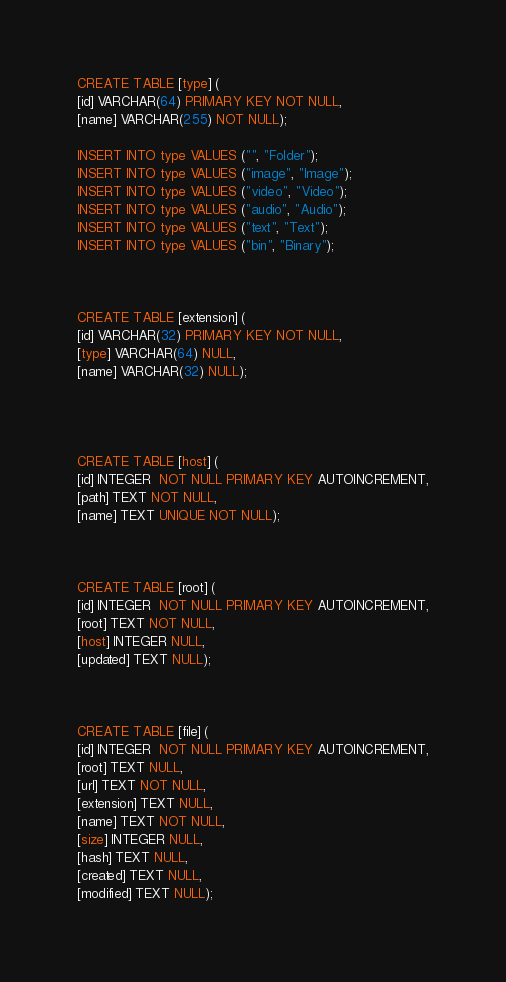Convert code to text. <code><loc_0><loc_0><loc_500><loc_500><_SQL_>
CREATE TABLE [type] (
[id] VARCHAR(64) PRIMARY KEY NOT NULL,
[name] VARCHAR(255) NOT NULL);

INSERT INTO type VALUES ("", "Folder");
INSERT INTO type VALUES ("image", "Image");
INSERT INTO type VALUES ("video", "Video");
INSERT INTO type VALUES ("audio", "Audio");
INSERT INTO type VALUES ("text", "Text");
INSERT INTO type VALUES ("bin", "Binary");



CREATE TABLE [extension] (
[id] VARCHAR(32) PRIMARY KEY NOT NULL,
[type] VARCHAR(64) NULL,
[name] VARCHAR(32) NULL);




CREATE TABLE [host] (
[id] INTEGER  NOT NULL PRIMARY KEY AUTOINCREMENT,
[path] TEXT NOT NULL,
[name] TEXT UNIQUE NOT NULL);



CREATE TABLE [root] (
[id] INTEGER  NOT NULL PRIMARY KEY AUTOINCREMENT,
[root] TEXT NOT NULL,
[host] INTEGER NULL,
[updated] TEXT NULL);



CREATE TABLE [file] (
[id] INTEGER  NOT NULL PRIMARY KEY AUTOINCREMENT,
[root] TEXT NULL,
[url] TEXT NOT NULL,
[extension] TEXT NULL,
[name] TEXT NOT NULL,
[size] INTEGER NULL,
[hash] TEXT NULL,
[created] TEXT NULL,
[modified] TEXT NULL);
</code> 